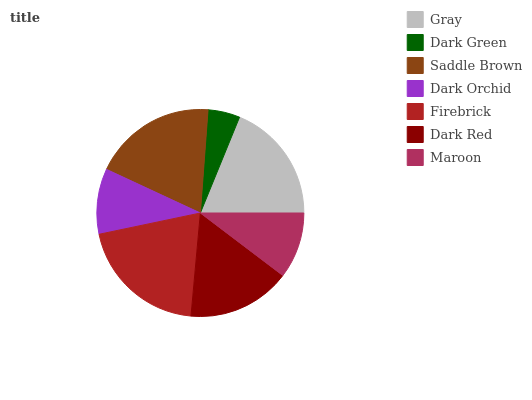Is Dark Green the minimum?
Answer yes or no. Yes. Is Firebrick the maximum?
Answer yes or no. Yes. Is Saddle Brown the minimum?
Answer yes or no. No. Is Saddle Brown the maximum?
Answer yes or no. No. Is Saddle Brown greater than Dark Green?
Answer yes or no. Yes. Is Dark Green less than Saddle Brown?
Answer yes or no. Yes. Is Dark Green greater than Saddle Brown?
Answer yes or no. No. Is Saddle Brown less than Dark Green?
Answer yes or no. No. Is Dark Red the high median?
Answer yes or no. Yes. Is Dark Red the low median?
Answer yes or no. Yes. Is Dark Green the high median?
Answer yes or no. No. Is Dark Green the low median?
Answer yes or no. No. 